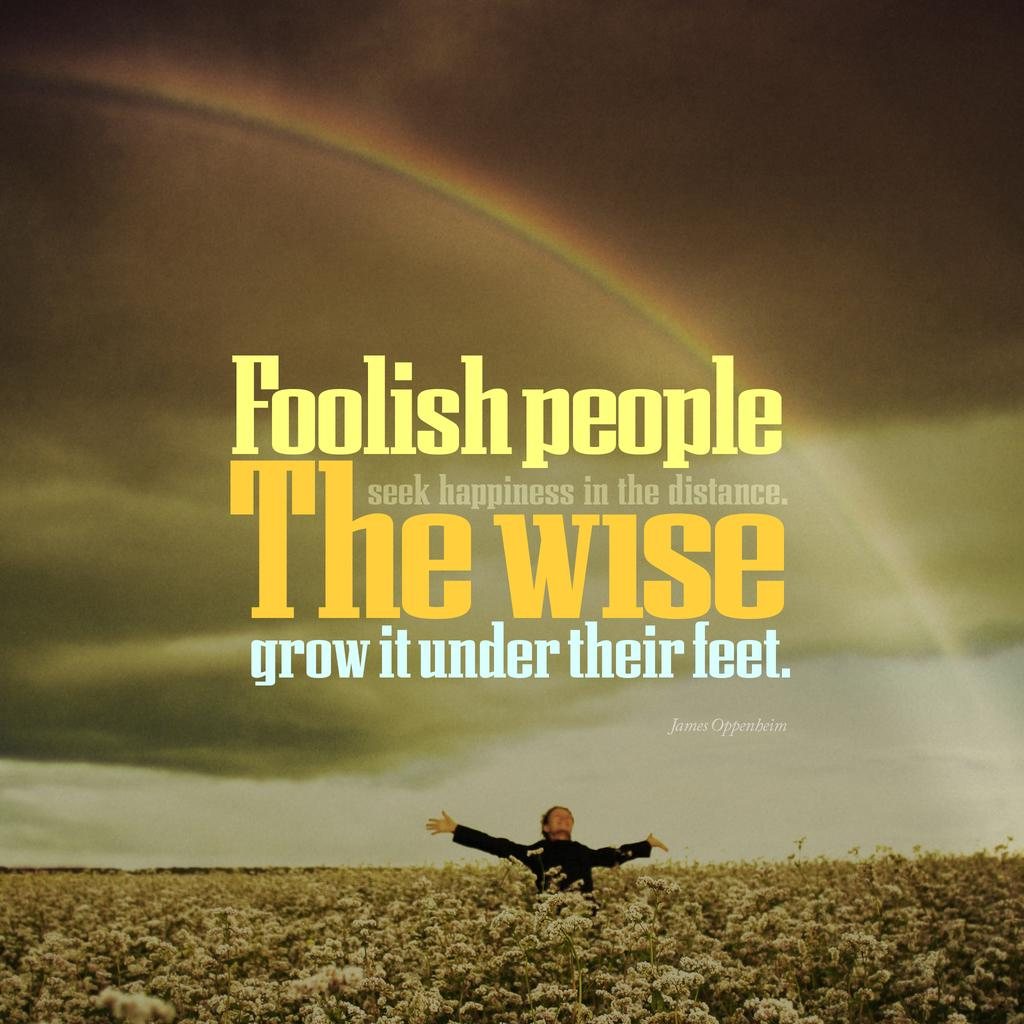<image>
Summarize the visual content of the image. A poster with the phrase Foolish People seek happiness in the distance. The Wise grow it under their feet. 